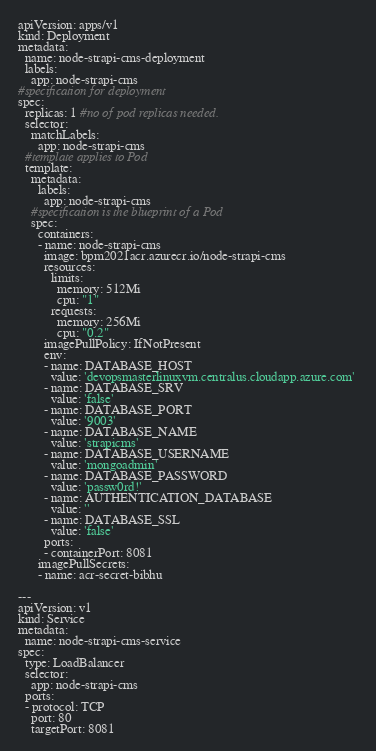Convert code to text. <code><loc_0><loc_0><loc_500><loc_500><_YAML_>apiVersion: apps/v1
kind: Deployment
metadata:
  name: node-strapi-cms-deployment
  labels: 
    app: node-strapi-cms
#specification for deployment
spec:
  replicas: 1 #no of pod replicas needed.
  selector:
    matchLabels:
      app: node-strapi-cms
  #template applies to Pod
  template: 
    metadata:
      labels:
        app: node-strapi-cms
    #specification is the blueprint of a Pod
    spec:
      containers:   
      - name: node-strapi-cms
        image: bpm2021acr.azurecr.io/node-strapi-cms
        resources:
          limits:
            memory: 512Mi
            cpu: "1"
          requests:
            memory: 256Mi
            cpu: "0.2"
        imagePullPolicy: IfNotPresent
        env: 
        - name: DATABASE_HOST
          value: 'devopsmasterlinuxvm.centralus.cloudapp.azure.com' 
        - name: DATABASE_SRV
          value: 'false' 
        - name: DATABASE_PORT
          value: '9003' 
        - name: DATABASE_NAME
          value: 'strapicms' 
        - name: DATABASE_USERNAME
          value: 'mongoadmin' 
        - name: DATABASE_PASSWORD
          value: 'passw0rd!' 
        - name: AUTHENTICATION_DATABASE
          value: '' 
        - name: DATABASE_SSL
          value: 'false' 
        ports:
        - containerPort: 8081    
      imagePullSecrets:
      - name: acr-secret-bibhu 

---
apiVersion: v1
kind: Service
metadata: 
  name: node-strapi-cms-service  
spec:
  type: LoadBalancer
  selector: 
    app: node-strapi-cms
  ports:
  - protocol: TCP
    port: 80
    targetPort: 8081</code> 